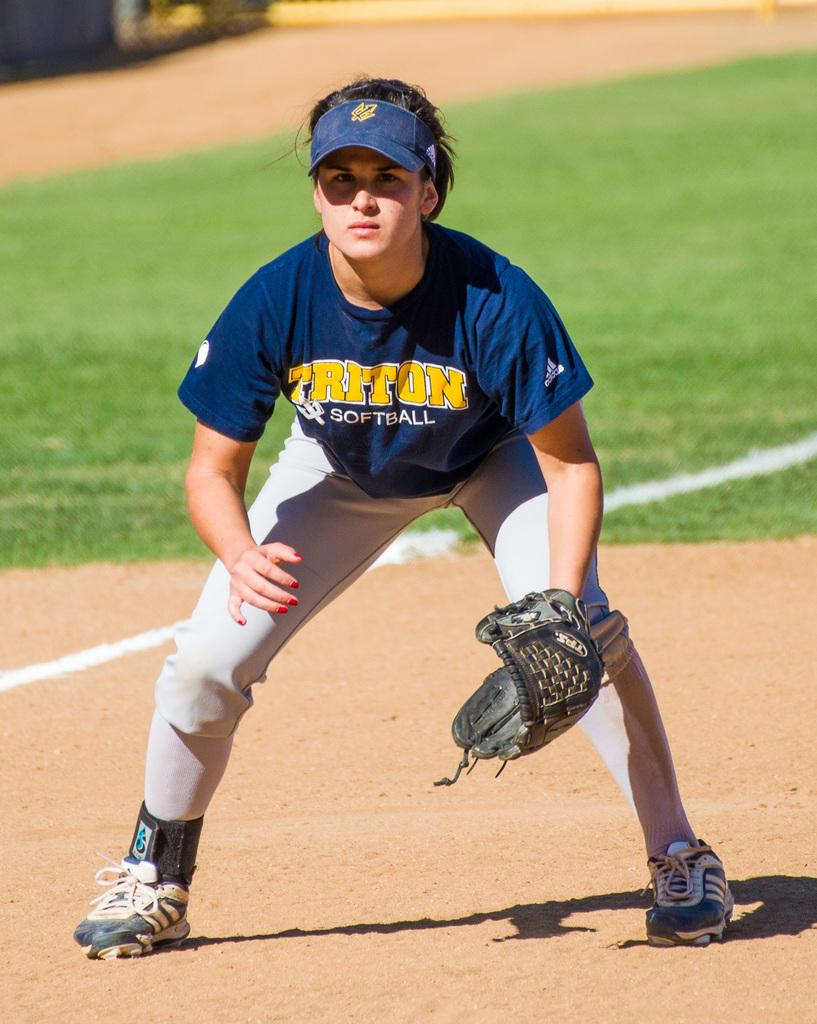<image>
Offer a succinct explanation of the picture presented. A female Triton softball player leans over on the field awaiting the next play. 